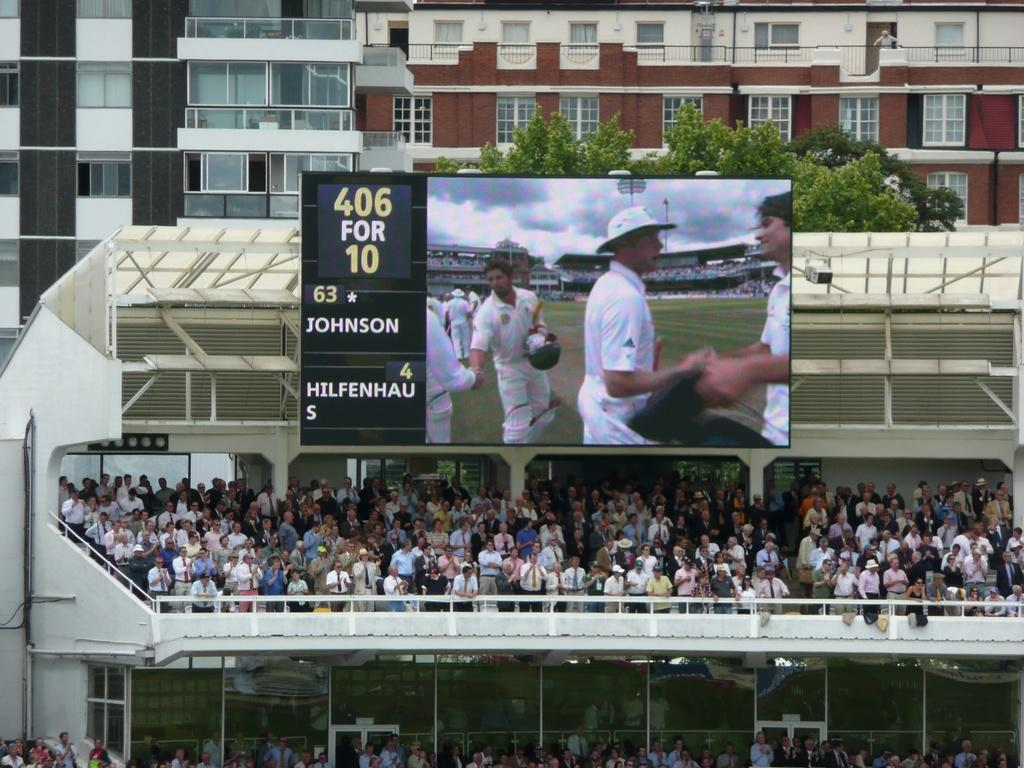<image>
Create a compact narrative representing the image presented. Spectators at a cricket game where Johnson and Hilfenhaus are playing 